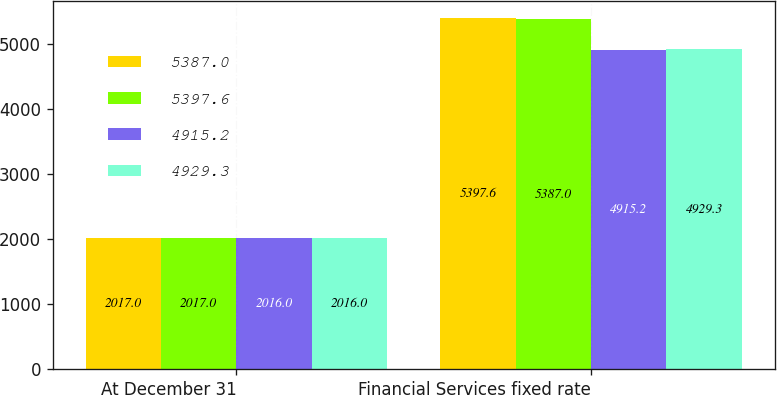<chart> <loc_0><loc_0><loc_500><loc_500><stacked_bar_chart><ecel><fcel>At December 31<fcel>Financial Services fixed rate<nl><fcel>5387<fcel>2017<fcel>5397.6<nl><fcel>5397.6<fcel>2017<fcel>5387<nl><fcel>4915.2<fcel>2016<fcel>4915.2<nl><fcel>4929.3<fcel>2016<fcel>4929.3<nl></chart> 